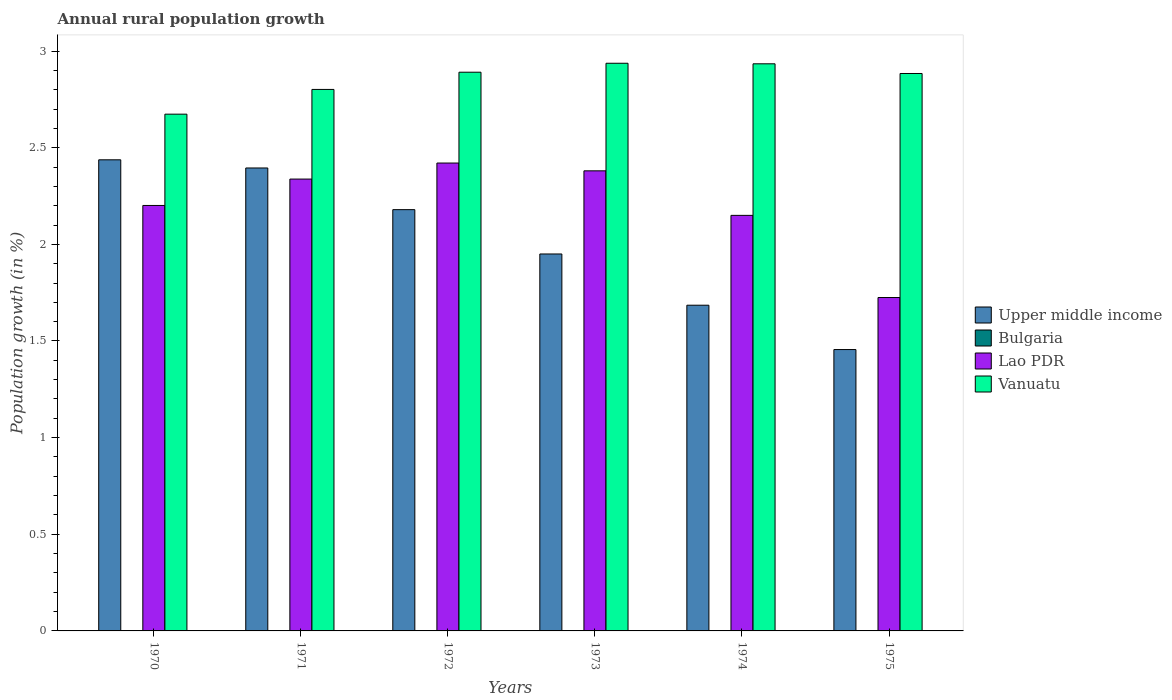Are the number of bars per tick equal to the number of legend labels?
Give a very brief answer. No. What is the label of the 6th group of bars from the left?
Give a very brief answer. 1975. In how many cases, is the number of bars for a given year not equal to the number of legend labels?
Offer a terse response. 6. What is the percentage of rural population growth in Vanuatu in 1974?
Your answer should be very brief. 2.93. Across all years, what is the maximum percentage of rural population growth in Upper middle income?
Provide a short and direct response. 2.44. Across all years, what is the minimum percentage of rural population growth in Bulgaria?
Provide a short and direct response. 0. What is the total percentage of rural population growth in Lao PDR in the graph?
Make the answer very short. 13.21. What is the difference between the percentage of rural population growth in Upper middle income in 1971 and that in 1974?
Keep it short and to the point. 0.71. What is the difference between the percentage of rural population growth in Bulgaria in 1975 and the percentage of rural population growth in Upper middle income in 1972?
Ensure brevity in your answer.  -2.18. What is the average percentage of rural population growth in Bulgaria per year?
Your answer should be very brief. 0. In the year 1972, what is the difference between the percentage of rural population growth in Upper middle income and percentage of rural population growth in Vanuatu?
Offer a terse response. -0.71. What is the ratio of the percentage of rural population growth in Lao PDR in 1970 to that in 1975?
Your answer should be very brief. 1.28. Is the percentage of rural population growth in Vanuatu in 1970 less than that in 1971?
Keep it short and to the point. Yes. What is the difference between the highest and the second highest percentage of rural population growth in Lao PDR?
Your answer should be compact. 0.04. What is the difference between the highest and the lowest percentage of rural population growth in Lao PDR?
Keep it short and to the point. 0.7. In how many years, is the percentage of rural population growth in Lao PDR greater than the average percentage of rural population growth in Lao PDR taken over all years?
Provide a short and direct response. 3. Is it the case that in every year, the sum of the percentage of rural population growth in Bulgaria and percentage of rural population growth in Lao PDR is greater than the sum of percentage of rural population growth in Vanuatu and percentage of rural population growth in Upper middle income?
Provide a succinct answer. No. Is it the case that in every year, the sum of the percentage of rural population growth in Vanuatu and percentage of rural population growth in Upper middle income is greater than the percentage of rural population growth in Bulgaria?
Make the answer very short. Yes. How many bars are there?
Your response must be concise. 18. Does the graph contain any zero values?
Give a very brief answer. Yes. Where does the legend appear in the graph?
Your answer should be very brief. Center right. How many legend labels are there?
Keep it short and to the point. 4. How are the legend labels stacked?
Your response must be concise. Vertical. What is the title of the graph?
Your response must be concise. Annual rural population growth. What is the label or title of the Y-axis?
Your response must be concise. Population growth (in %). What is the Population growth (in %) in Upper middle income in 1970?
Your answer should be compact. 2.44. What is the Population growth (in %) in Lao PDR in 1970?
Provide a short and direct response. 2.2. What is the Population growth (in %) of Vanuatu in 1970?
Offer a very short reply. 2.67. What is the Population growth (in %) in Upper middle income in 1971?
Provide a succinct answer. 2.4. What is the Population growth (in %) in Bulgaria in 1971?
Your answer should be compact. 0. What is the Population growth (in %) in Lao PDR in 1971?
Ensure brevity in your answer.  2.34. What is the Population growth (in %) of Vanuatu in 1971?
Ensure brevity in your answer.  2.8. What is the Population growth (in %) of Upper middle income in 1972?
Provide a short and direct response. 2.18. What is the Population growth (in %) in Bulgaria in 1972?
Your answer should be very brief. 0. What is the Population growth (in %) in Lao PDR in 1972?
Offer a terse response. 2.42. What is the Population growth (in %) of Vanuatu in 1972?
Provide a succinct answer. 2.89. What is the Population growth (in %) in Upper middle income in 1973?
Your answer should be compact. 1.95. What is the Population growth (in %) of Bulgaria in 1973?
Your response must be concise. 0. What is the Population growth (in %) of Lao PDR in 1973?
Ensure brevity in your answer.  2.38. What is the Population growth (in %) in Vanuatu in 1973?
Your answer should be compact. 2.94. What is the Population growth (in %) in Upper middle income in 1974?
Provide a succinct answer. 1.69. What is the Population growth (in %) of Lao PDR in 1974?
Your response must be concise. 2.15. What is the Population growth (in %) in Vanuatu in 1974?
Offer a very short reply. 2.93. What is the Population growth (in %) of Upper middle income in 1975?
Your answer should be compact. 1.46. What is the Population growth (in %) of Lao PDR in 1975?
Ensure brevity in your answer.  1.72. What is the Population growth (in %) of Vanuatu in 1975?
Keep it short and to the point. 2.88. Across all years, what is the maximum Population growth (in %) of Upper middle income?
Make the answer very short. 2.44. Across all years, what is the maximum Population growth (in %) of Lao PDR?
Give a very brief answer. 2.42. Across all years, what is the maximum Population growth (in %) in Vanuatu?
Give a very brief answer. 2.94. Across all years, what is the minimum Population growth (in %) of Upper middle income?
Your answer should be compact. 1.46. Across all years, what is the minimum Population growth (in %) of Lao PDR?
Your response must be concise. 1.72. Across all years, what is the minimum Population growth (in %) of Vanuatu?
Ensure brevity in your answer.  2.67. What is the total Population growth (in %) of Upper middle income in the graph?
Offer a very short reply. 12.1. What is the total Population growth (in %) of Lao PDR in the graph?
Give a very brief answer. 13.21. What is the total Population growth (in %) in Vanuatu in the graph?
Provide a succinct answer. 17.12. What is the difference between the Population growth (in %) in Upper middle income in 1970 and that in 1971?
Keep it short and to the point. 0.04. What is the difference between the Population growth (in %) of Lao PDR in 1970 and that in 1971?
Provide a succinct answer. -0.14. What is the difference between the Population growth (in %) in Vanuatu in 1970 and that in 1971?
Give a very brief answer. -0.13. What is the difference between the Population growth (in %) in Upper middle income in 1970 and that in 1972?
Provide a short and direct response. 0.26. What is the difference between the Population growth (in %) in Lao PDR in 1970 and that in 1972?
Offer a terse response. -0.22. What is the difference between the Population growth (in %) in Vanuatu in 1970 and that in 1972?
Offer a very short reply. -0.22. What is the difference between the Population growth (in %) in Upper middle income in 1970 and that in 1973?
Your answer should be very brief. 0.49. What is the difference between the Population growth (in %) of Lao PDR in 1970 and that in 1973?
Provide a succinct answer. -0.18. What is the difference between the Population growth (in %) of Vanuatu in 1970 and that in 1973?
Ensure brevity in your answer.  -0.26. What is the difference between the Population growth (in %) in Upper middle income in 1970 and that in 1974?
Make the answer very short. 0.75. What is the difference between the Population growth (in %) of Lao PDR in 1970 and that in 1974?
Your response must be concise. 0.05. What is the difference between the Population growth (in %) in Vanuatu in 1970 and that in 1974?
Your answer should be very brief. -0.26. What is the difference between the Population growth (in %) of Upper middle income in 1970 and that in 1975?
Your answer should be very brief. 0.98. What is the difference between the Population growth (in %) of Lao PDR in 1970 and that in 1975?
Keep it short and to the point. 0.48. What is the difference between the Population growth (in %) in Vanuatu in 1970 and that in 1975?
Make the answer very short. -0.21. What is the difference between the Population growth (in %) of Upper middle income in 1971 and that in 1972?
Make the answer very short. 0.22. What is the difference between the Population growth (in %) in Lao PDR in 1971 and that in 1972?
Offer a very short reply. -0.08. What is the difference between the Population growth (in %) of Vanuatu in 1971 and that in 1972?
Your response must be concise. -0.09. What is the difference between the Population growth (in %) of Upper middle income in 1971 and that in 1973?
Your response must be concise. 0.44. What is the difference between the Population growth (in %) in Lao PDR in 1971 and that in 1973?
Offer a terse response. -0.04. What is the difference between the Population growth (in %) in Vanuatu in 1971 and that in 1973?
Give a very brief answer. -0.14. What is the difference between the Population growth (in %) of Upper middle income in 1971 and that in 1974?
Provide a short and direct response. 0.71. What is the difference between the Population growth (in %) of Lao PDR in 1971 and that in 1974?
Provide a succinct answer. 0.19. What is the difference between the Population growth (in %) of Vanuatu in 1971 and that in 1974?
Your response must be concise. -0.13. What is the difference between the Population growth (in %) in Upper middle income in 1971 and that in 1975?
Give a very brief answer. 0.94. What is the difference between the Population growth (in %) in Lao PDR in 1971 and that in 1975?
Offer a terse response. 0.61. What is the difference between the Population growth (in %) in Vanuatu in 1971 and that in 1975?
Provide a succinct answer. -0.08. What is the difference between the Population growth (in %) of Upper middle income in 1972 and that in 1973?
Provide a short and direct response. 0.23. What is the difference between the Population growth (in %) of Lao PDR in 1972 and that in 1973?
Ensure brevity in your answer.  0.04. What is the difference between the Population growth (in %) of Vanuatu in 1972 and that in 1973?
Your answer should be very brief. -0.05. What is the difference between the Population growth (in %) of Upper middle income in 1972 and that in 1974?
Provide a short and direct response. 0.49. What is the difference between the Population growth (in %) in Lao PDR in 1972 and that in 1974?
Keep it short and to the point. 0.27. What is the difference between the Population growth (in %) of Vanuatu in 1972 and that in 1974?
Provide a short and direct response. -0.04. What is the difference between the Population growth (in %) of Upper middle income in 1972 and that in 1975?
Provide a succinct answer. 0.72. What is the difference between the Population growth (in %) in Lao PDR in 1972 and that in 1975?
Ensure brevity in your answer.  0.7. What is the difference between the Population growth (in %) in Vanuatu in 1972 and that in 1975?
Offer a terse response. 0.01. What is the difference between the Population growth (in %) of Upper middle income in 1973 and that in 1974?
Keep it short and to the point. 0.27. What is the difference between the Population growth (in %) of Lao PDR in 1973 and that in 1974?
Provide a succinct answer. 0.23. What is the difference between the Population growth (in %) in Vanuatu in 1973 and that in 1974?
Give a very brief answer. 0. What is the difference between the Population growth (in %) in Upper middle income in 1973 and that in 1975?
Ensure brevity in your answer.  0.49. What is the difference between the Population growth (in %) of Lao PDR in 1973 and that in 1975?
Provide a succinct answer. 0.66. What is the difference between the Population growth (in %) of Vanuatu in 1973 and that in 1975?
Ensure brevity in your answer.  0.05. What is the difference between the Population growth (in %) in Upper middle income in 1974 and that in 1975?
Offer a terse response. 0.23. What is the difference between the Population growth (in %) in Lao PDR in 1974 and that in 1975?
Your answer should be compact. 0.43. What is the difference between the Population growth (in %) in Vanuatu in 1974 and that in 1975?
Ensure brevity in your answer.  0.05. What is the difference between the Population growth (in %) in Upper middle income in 1970 and the Population growth (in %) in Lao PDR in 1971?
Your answer should be very brief. 0.1. What is the difference between the Population growth (in %) of Upper middle income in 1970 and the Population growth (in %) of Vanuatu in 1971?
Ensure brevity in your answer.  -0.36. What is the difference between the Population growth (in %) of Lao PDR in 1970 and the Population growth (in %) of Vanuatu in 1971?
Ensure brevity in your answer.  -0.6. What is the difference between the Population growth (in %) in Upper middle income in 1970 and the Population growth (in %) in Lao PDR in 1972?
Provide a short and direct response. 0.02. What is the difference between the Population growth (in %) of Upper middle income in 1970 and the Population growth (in %) of Vanuatu in 1972?
Give a very brief answer. -0.45. What is the difference between the Population growth (in %) of Lao PDR in 1970 and the Population growth (in %) of Vanuatu in 1972?
Provide a succinct answer. -0.69. What is the difference between the Population growth (in %) in Upper middle income in 1970 and the Population growth (in %) in Lao PDR in 1973?
Your answer should be compact. 0.06. What is the difference between the Population growth (in %) of Upper middle income in 1970 and the Population growth (in %) of Vanuatu in 1973?
Your answer should be very brief. -0.5. What is the difference between the Population growth (in %) in Lao PDR in 1970 and the Population growth (in %) in Vanuatu in 1973?
Your response must be concise. -0.74. What is the difference between the Population growth (in %) in Upper middle income in 1970 and the Population growth (in %) in Lao PDR in 1974?
Your response must be concise. 0.29. What is the difference between the Population growth (in %) in Upper middle income in 1970 and the Population growth (in %) in Vanuatu in 1974?
Ensure brevity in your answer.  -0.5. What is the difference between the Population growth (in %) in Lao PDR in 1970 and the Population growth (in %) in Vanuatu in 1974?
Your answer should be very brief. -0.73. What is the difference between the Population growth (in %) of Upper middle income in 1970 and the Population growth (in %) of Lao PDR in 1975?
Keep it short and to the point. 0.71. What is the difference between the Population growth (in %) in Upper middle income in 1970 and the Population growth (in %) in Vanuatu in 1975?
Give a very brief answer. -0.45. What is the difference between the Population growth (in %) of Lao PDR in 1970 and the Population growth (in %) of Vanuatu in 1975?
Your response must be concise. -0.68. What is the difference between the Population growth (in %) in Upper middle income in 1971 and the Population growth (in %) in Lao PDR in 1972?
Your response must be concise. -0.03. What is the difference between the Population growth (in %) in Upper middle income in 1971 and the Population growth (in %) in Vanuatu in 1972?
Make the answer very short. -0.5. What is the difference between the Population growth (in %) of Lao PDR in 1971 and the Population growth (in %) of Vanuatu in 1972?
Provide a short and direct response. -0.55. What is the difference between the Population growth (in %) in Upper middle income in 1971 and the Population growth (in %) in Lao PDR in 1973?
Your answer should be very brief. 0.01. What is the difference between the Population growth (in %) in Upper middle income in 1971 and the Population growth (in %) in Vanuatu in 1973?
Your response must be concise. -0.54. What is the difference between the Population growth (in %) in Lao PDR in 1971 and the Population growth (in %) in Vanuatu in 1973?
Offer a very short reply. -0.6. What is the difference between the Population growth (in %) of Upper middle income in 1971 and the Population growth (in %) of Lao PDR in 1974?
Offer a very short reply. 0.25. What is the difference between the Population growth (in %) in Upper middle income in 1971 and the Population growth (in %) in Vanuatu in 1974?
Your response must be concise. -0.54. What is the difference between the Population growth (in %) of Lao PDR in 1971 and the Population growth (in %) of Vanuatu in 1974?
Provide a short and direct response. -0.6. What is the difference between the Population growth (in %) of Upper middle income in 1971 and the Population growth (in %) of Lao PDR in 1975?
Ensure brevity in your answer.  0.67. What is the difference between the Population growth (in %) of Upper middle income in 1971 and the Population growth (in %) of Vanuatu in 1975?
Offer a terse response. -0.49. What is the difference between the Population growth (in %) in Lao PDR in 1971 and the Population growth (in %) in Vanuatu in 1975?
Provide a short and direct response. -0.55. What is the difference between the Population growth (in %) of Upper middle income in 1972 and the Population growth (in %) of Lao PDR in 1973?
Keep it short and to the point. -0.2. What is the difference between the Population growth (in %) of Upper middle income in 1972 and the Population growth (in %) of Vanuatu in 1973?
Provide a succinct answer. -0.76. What is the difference between the Population growth (in %) in Lao PDR in 1972 and the Population growth (in %) in Vanuatu in 1973?
Provide a succinct answer. -0.52. What is the difference between the Population growth (in %) of Upper middle income in 1972 and the Population growth (in %) of Lao PDR in 1974?
Your answer should be very brief. 0.03. What is the difference between the Population growth (in %) in Upper middle income in 1972 and the Population growth (in %) in Vanuatu in 1974?
Your answer should be very brief. -0.75. What is the difference between the Population growth (in %) of Lao PDR in 1972 and the Population growth (in %) of Vanuatu in 1974?
Ensure brevity in your answer.  -0.51. What is the difference between the Population growth (in %) of Upper middle income in 1972 and the Population growth (in %) of Lao PDR in 1975?
Keep it short and to the point. 0.45. What is the difference between the Population growth (in %) in Upper middle income in 1972 and the Population growth (in %) in Vanuatu in 1975?
Offer a terse response. -0.7. What is the difference between the Population growth (in %) of Lao PDR in 1972 and the Population growth (in %) of Vanuatu in 1975?
Offer a terse response. -0.46. What is the difference between the Population growth (in %) in Upper middle income in 1973 and the Population growth (in %) in Lao PDR in 1974?
Your answer should be compact. -0.2. What is the difference between the Population growth (in %) in Upper middle income in 1973 and the Population growth (in %) in Vanuatu in 1974?
Your answer should be very brief. -0.98. What is the difference between the Population growth (in %) of Lao PDR in 1973 and the Population growth (in %) of Vanuatu in 1974?
Offer a terse response. -0.55. What is the difference between the Population growth (in %) of Upper middle income in 1973 and the Population growth (in %) of Lao PDR in 1975?
Your answer should be very brief. 0.23. What is the difference between the Population growth (in %) in Upper middle income in 1973 and the Population growth (in %) in Vanuatu in 1975?
Your answer should be compact. -0.93. What is the difference between the Population growth (in %) of Lao PDR in 1973 and the Population growth (in %) of Vanuatu in 1975?
Offer a very short reply. -0.5. What is the difference between the Population growth (in %) in Upper middle income in 1974 and the Population growth (in %) in Lao PDR in 1975?
Make the answer very short. -0.04. What is the difference between the Population growth (in %) of Upper middle income in 1974 and the Population growth (in %) of Vanuatu in 1975?
Ensure brevity in your answer.  -1.2. What is the difference between the Population growth (in %) in Lao PDR in 1974 and the Population growth (in %) in Vanuatu in 1975?
Give a very brief answer. -0.73. What is the average Population growth (in %) of Upper middle income per year?
Provide a succinct answer. 2.02. What is the average Population growth (in %) of Bulgaria per year?
Keep it short and to the point. 0. What is the average Population growth (in %) of Lao PDR per year?
Provide a succinct answer. 2.2. What is the average Population growth (in %) of Vanuatu per year?
Provide a succinct answer. 2.85. In the year 1970, what is the difference between the Population growth (in %) of Upper middle income and Population growth (in %) of Lao PDR?
Your answer should be compact. 0.24. In the year 1970, what is the difference between the Population growth (in %) of Upper middle income and Population growth (in %) of Vanuatu?
Offer a terse response. -0.24. In the year 1970, what is the difference between the Population growth (in %) in Lao PDR and Population growth (in %) in Vanuatu?
Offer a terse response. -0.47. In the year 1971, what is the difference between the Population growth (in %) in Upper middle income and Population growth (in %) in Lao PDR?
Ensure brevity in your answer.  0.06. In the year 1971, what is the difference between the Population growth (in %) in Upper middle income and Population growth (in %) in Vanuatu?
Give a very brief answer. -0.41. In the year 1971, what is the difference between the Population growth (in %) of Lao PDR and Population growth (in %) of Vanuatu?
Provide a short and direct response. -0.46. In the year 1972, what is the difference between the Population growth (in %) of Upper middle income and Population growth (in %) of Lao PDR?
Offer a terse response. -0.24. In the year 1972, what is the difference between the Population growth (in %) of Upper middle income and Population growth (in %) of Vanuatu?
Offer a very short reply. -0.71. In the year 1972, what is the difference between the Population growth (in %) of Lao PDR and Population growth (in %) of Vanuatu?
Offer a very short reply. -0.47. In the year 1973, what is the difference between the Population growth (in %) of Upper middle income and Population growth (in %) of Lao PDR?
Your answer should be compact. -0.43. In the year 1973, what is the difference between the Population growth (in %) in Upper middle income and Population growth (in %) in Vanuatu?
Provide a short and direct response. -0.99. In the year 1973, what is the difference between the Population growth (in %) in Lao PDR and Population growth (in %) in Vanuatu?
Your answer should be very brief. -0.56. In the year 1974, what is the difference between the Population growth (in %) in Upper middle income and Population growth (in %) in Lao PDR?
Keep it short and to the point. -0.46. In the year 1974, what is the difference between the Population growth (in %) in Upper middle income and Population growth (in %) in Vanuatu?
Offer a very short reply. -1.25. In the year 1974, what is the difference between the Population growth (in %) in Lao PDR and Population growth (in %) in Vanuatu?
Keep it short and to the point. -0.78. In the year 1975, what is the difference between the Population growth (in %) of Upper middle income and Population growth (in %) of Lao PDR?
Your response must be concise. -0.27. In the year 1975, what is the difference between the Population growth (in %) in Upper middle income and Population growth (in %) in Vanuatu?
Provide a succinct answer. -1.43. In the year 1975, what is the difference between the Population growth (in %) in Lao PDR and Population growth (in %) in Vanuatu?
Provide a succinct answer. -1.16. What is the ratio of the Population growth (in %) of Upper middle income in 1970 to that in 1971?
Provide a short and direct response. 1.02. What is the ratio of the Population growth (in %) in Lao PDR in 1970 to that in 1971?
Keep it short and to the point. 0.94. What is the ratio of the Population growth (in %) in Vanuatu in 1970 to that in 1971?
Your answer should be very brief. 0.95. What is the ratio of the Population growth (in %) of Upper middle income in 1970 to that in 1972?
Your response must be concise. 1.12. What is the ratio of the Population growth (in %) of Lao PDR in 1970 to that in 1972?
Your answer should be compact. 0.91. What is the ratio of the Population growth (in %) in Vanuatu in 1970 to that in 1972?
Your answer should be compact. 0.92. What is the ratio of the Population growth (in %) in Upper middle income in 1970 to that in 1973?
Provide a short and direct response. 1.25. What is the ratio of the Population growth (in %) of Lao PDR in 1970 to that in 1973?
Offer a terse response. 0.92. What is the ratio of the Population growth (in %) of Vanuatu in 1970 to that in 1973?
Make the answer very short. 0.91. What is the ratio of the Population growth (in %) in Upper middle income in 1970 to that in 1974?
Your answer should be very brief. 1.45. What is the ratio of the Population growth (in %) of Lao PDR in 1970 to that in 1974?
Your response must be concise. 1.02. What is the ratio of the Population growth (in %) in Vanuatu in 1970 to that in 1974?
Ensure brevity in your answer.  0.91. What is the ratio of the Population growth (in %) in Upper middle income in 1970 to that in 1975?
Make the answer very short. 1.67. What is the ratio of the Population growth (in %) in Lao PDR in 1970 to that in 1975?
Give a very brief answer. 1.28. What is the ratio of the Population growth (in %) of Vanuatu in 1970 to that in 1975?
Provide a succinct answer. 0.93. What is the ratio of the Population growth (in %) in Upper middle income in 1971 to that in 1972?
Offer a terse response. 1.1. What is the ratio of the Population growth (in %) in Lao PDR in 1971 to that in 1972?
Provide a short and direct response. 0.97. What is the ratio of the Population growth (in %) in Vanuatu in 1971 to that in 1972?
Give a very brief answer. 0.97. What is the ratio of the Population growth (in %) in Upper middle income in 1971 to that in 1973?
Provide a succinct answer. 1.23. What is the ratio of the Population growth (in %) in Lao PDR in 1971 to that in 1973?
Keep it short and to the point. 0.98. What is the ratio of the Population growth (in %) in Vanuatu in 1971 to that in 1973?
Keep it short and to the point. 0.95. What is the ratio of the Population growth (in %) of Upper middle income in 1971 to that in 1974?
Give a very brief answer. 1.42. What is the ratio of the Population growth (in %) of Lao PDR in 1971 to that in 1974?
Your answer should be very brief. 1.09. What is the ratio of the Population growth (in %) in Vanuatu in 1971 to that in 1974?
Your response must be concise. 0.95. What is the ratio of the Population growth (in %) of Upper middle income in 1971 to that in 1975?
Offer a terse response. 1.65. What is the ratio of the Population growth (in %) of Lao PDR in 1971 to that in 1975?
Your response must be concise. 1.36. What is the ratio of the Population growth (in %) of Vanuatu in 1971 to that in 1975?
Provide a succinct answer. 0.97. What is the ratio of the Population growth (in %) of Upper middle income in 1972 to that in 1973?
Keep it short and to the point. 1.12. What is the ratio of the Population growth (in %) in Lao PDR in 1972 to that in 1973?
Your response must be concise. 1.02. What is the ratio of the Population growth (in %) of Vanuatu in 1972 to that in 1973?
Provide a succinct answer. 0.98. What is the ratio of the Population growth (in %) of Upper middle income in 1972 to that in 1974?
Make the answer very short. 1.29. What is the ratio of the Population growth (in %) of Lao PDR in 1972 to that in 1974?
Your answer should be compact. 1.13. What is the ratio of the Population growth (in %) of Vanuatu in 1972 to that in 1974?
Your answer should be compact. 0.99. What is the ratio of the Population growth (in %) in Upper middle income in 1972 to that in 1975?
Provide a succinct answer. 1.5. What is the ratio of the Population growth (in %) in Lao PDR in 1972 to that in 1975?
Provide a succinct answer. 1.4. What is the ratio of the Population growth (in %) of Upper middle income in 1973 to that in 1974?
Offer a very short reply. 1.16. What is the ratio of the Population growth (in %) of Lao PDR in 1973 to that in 1974?
Make the answer very short. 1.11. What is the ratio of the Population growth (in %) in Upper middle income in 1973 to that in 1975?
Provide a succinct answer. 1.34. What is the ratio of the Population growth (in %) of Lao PDR in 1973 to that in 1975?
Make the answer very short. 1.38. What is the ratio of the Population growth (in %) of Vanuatu in 1973 to that in 1975?
Provide a succinct answer. 1.02. What is the ratio of the Population growth (in %) in Upper middle income in 1974 to that in 1975?
Offer a very short reply. 1.16. What is the ratio of the Population growth (in %) of Lao PDR in 1974 to that in 1975?
Offer a terse response. 1.25. What is the ratio of the Population growth (in %) in Vanuatu in 1974 to that in 1975?
Provide a short and direct response. 1.02. What is the difference between the highest and the second highest Population growth (in %) of Upper middle income?
Provide a succinct answer. 0.04. What is the difference between the highest and the second highest Population growth (in %) in Lao PDR?
Make the answer very short. 0.04. What is the difference between the highest and the second highest Population growth (in %) in Vanuatu?
Provide a succinct answer. 0. What is the difference between the highest and the lowest Population growth (in %) of Upper middle income?
Provide a short and direct response. 0.98. What is the difference between the highest and the lowest Population growth (in %) of Lao PDR?
Make the answer very short. 0.7. What is the difference between the highest and the lowest Population growth (in %) of Vanuatu?
Provide a succinct answer. 0.26. 